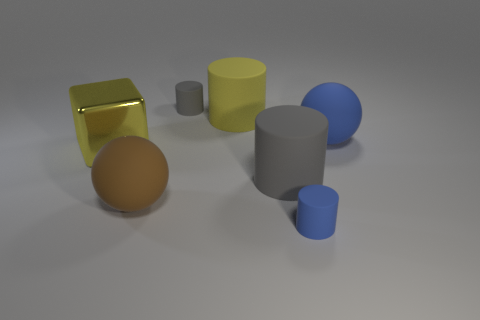Subtract all yellow spheres. Subtract all green cubes. How many spheres are left? 2 Subtract all brown blocks. How many purple balls are left? 0 Add 1 large yellows. How many tiny blues exist? 0 Subtract all blue rubber things. Subtract all purple things. How many objects are left? 5 Add 5 small blue things. How many small blue things are left? 6 Add 3 big purple rubber objects. How many big purple rubber objects exist? 3 Add 3 rubber objects. How many objects exist? 10 Subtract all brown balls. How many balls are left? 1 Subtract all blue matte cylinders. How many cylinders are left? 3 Subtract 1 yellow cubes. How many objects are left? 6 